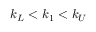Convert formula to latex. <formula><loc_0><loc_0><loc_500><loc_500>k _ { L } < k _ { 1 } < k _ { U }</formula> 